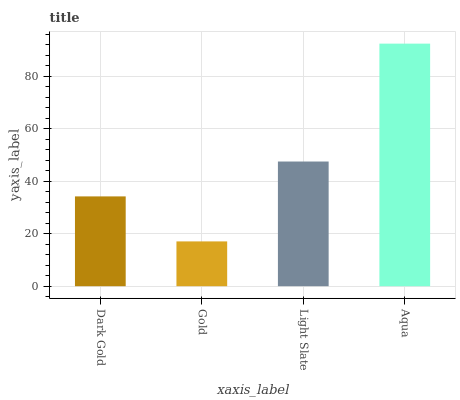Is Gold the minimum?
Answer yes or no. Yes. Is Aqua the maximum?
Answer yes or no. Yes. Is Light Slate the minimum?
Answer yes or no. No. Is Light Slate the maximum?
Answer yes or no. No. Is Light Slate greater than Gold?
Answer yes or no. Yes. Is Gold less than Light Slate?
Answer yes or no. Yes. Is Gold greater than Light Slate?
Answer yes or no. No. Is Light Slate less than Gold?
Answer yes or no. No. Is Light Slate the high median?
Answer yes or no. Yes. Is Dark Gold the low median?
Answer yes or no. Yes. Is Gold the high median?
Answer yes or no. No. Is Aqua the low median?
Answer yes or no. No. 